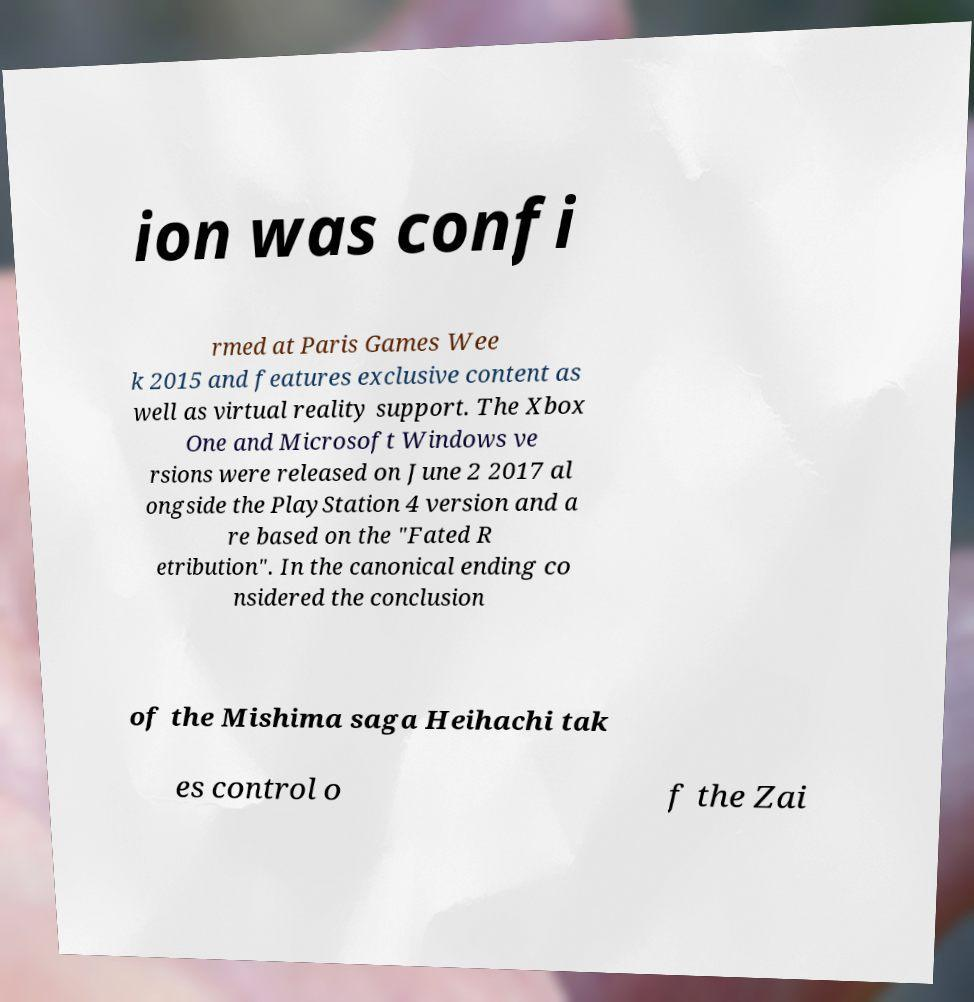Could you assist in decoding the text presented in this image and type it out clearly? ion was confi rmed at Paris Games Wee k 2015 and features exclusive content as well as virtual reality support. The Xbox One and Microsoft Windows ve rsions were released on June 2 2017 al ongside the PlayStation 4 version and a re based on the "Fated R etribution". In the canonical ending co nsidered the conclusion of the Mishima saga Heihachi tak es control o f the Zai 